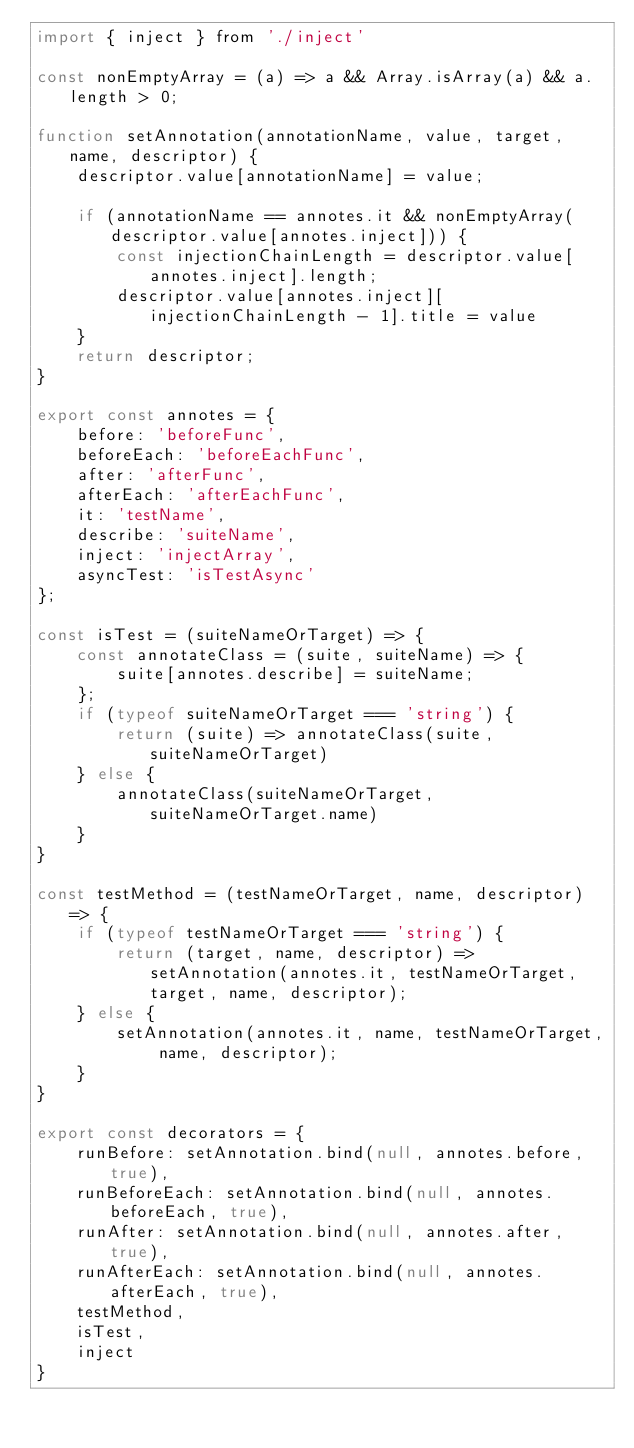<code> <loc_0><loc_0><loc_500><loc_500><_JavaScript_>import { inject } from './inject'

const nonEmptyArray = (a) => a && Array.isArray(a) && a.length > 0;

function setAnnotation(annotationName, value, target, name, descriptor) {
    descriptor.value[annotationName] = value;

    if (annotationName == annotes.it && nonEmptyArray(descriptor.value[annotes.inject])) {
        const injectionChainLength = descriptor.value[annotes.inject].length;
        descriptor.value[annotes.inject][injectionChainLength - 1].title = value
    }
    return descriptor;
}

export const annotes = {
    before: 'beforeFunc',
    beforeEach: 'beforeEachFunc',
    after: 'afterFunc',
    afterEach: 'afterEachFunc',
    it: 'testName',
    describe: 'suiteName',
    inject: 'injectArray',
    asyncTest: 'isTestAsync'
};

const isTest = (suiteNameOrTarget) => {
    const annotateClass = (suite, suiteName) => {
        suite[annotes.describe] = suiteName;
    };
    if (typeof suiteNameOrTarget === 'string') {
        return (suite) => annotateClass(suite, suiteNameOrTarget)
    } else {
        annotateClass(suiteNameOrTarget, suiteNameOrTarget.name)
    }
}

const testMethod = (testNameOrTarget, name, descriptor) => {
    if (typeof testNameOrTarget === 'string') {
        return (target, name, descriptor) => setAnnotation(annotes.it, testNameOrTarget, target, name, descriptor);
    } else {
        setAnnotation(annotes.it, name, testNameOrTarget, name, descriptor);
    }
}

export const decorators = {
    runBefore: setAnnotation.bind(null, annotes.before, true),
    runBeforeEach: setAnnotation.bind(null, annotes.beforeEach, true),
    runAfter: setAnnotation.bind(null, annotes.after, true),
    runAfterEach: setAnnotation.bind(null, annotes.afterEach, true),
    testMethod,
    isTest,
    inject
}</code> 